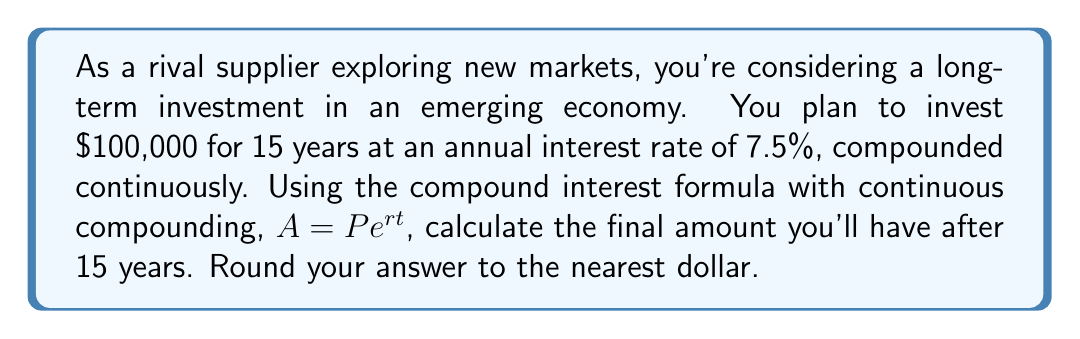Could you help me with this problem? To solve this problem, we'll use the compound interest formula for continuous compounding:

$$ A = P e^{rt} $$

Where:
$A$ = final amount
$P$ = principal (initial investment)
$e$ = Euler's number (approximately 2.71828)
$r$ = annual interest rate (as a decimal)
$t$ = time in years

Given:
$P = 100,000$
$r = 0.075$ (7.5% expressed as a decimal)
$t = 15$ years

Let's substitute these values into the formula:

$$ A = 100,000 \cdot e^{0.075 \cdot 15} $$

Now, let's calculate the exponent:
$$ 0.075 \cdot 15 = 1.125 $$

Our equation becomes:
$$ A = 100,000 \cdot e^{1.125} $$

Using a calculator or computer to evaluate $e^{1.125}$, we get approximately 3.08021.

So, our final calculation is:
$$ A = 100,000 \cdot 3.08021 = 308,021 $$

Rounding to the nearest dollar, we get $308,021.
Answer: $308,021 